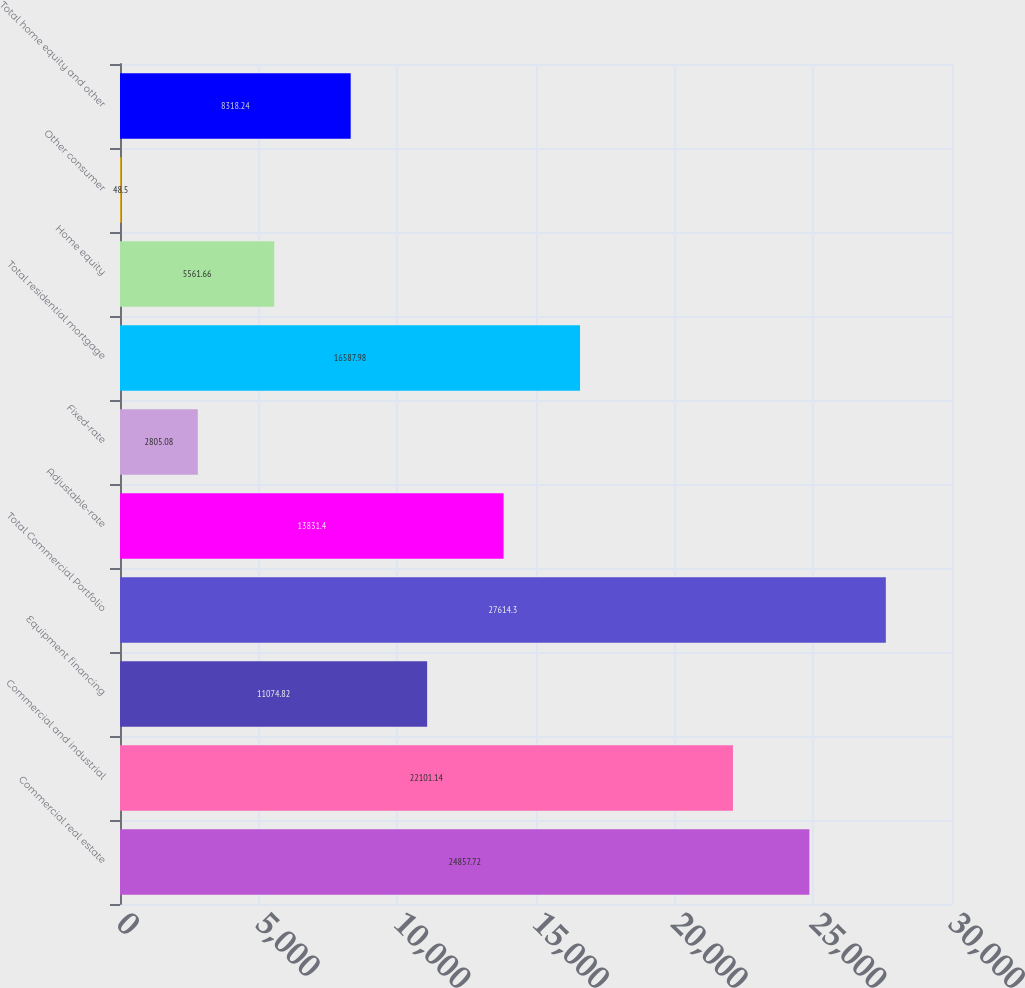Convert chart to OTSL. <chart><loc_0><loc_0><loc_500><loc_500><bar_chart><fcel>Commercial real estate<fcel>Commercial and industrial<fcel>Equipment financing<fcel>Total Commercial Portfolio<fcel>Adjustable-rate<fcel>Fixed-rate<fcel>Total residential mortgage<fcel>Home equity<fcel>Other consumer<fcel>Total home equity and other<nl><fcel>24857.7<fcel>22101.1<fcel>11074.8<fcel>27614.3<fcel>13831.4<fcel>2805.08<fcel>16588<fcel>5561.66<fcel>48.5<fcel>8318.24<nl></chart> 